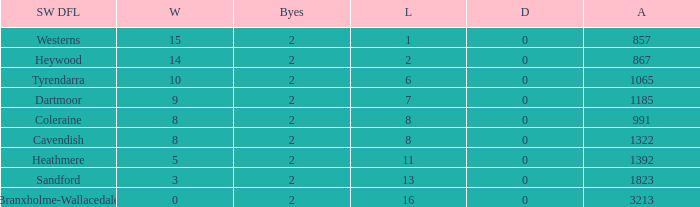Which Losses have a South West DFL of branxholme-wallacedale, and less than 2 Byes? None. 